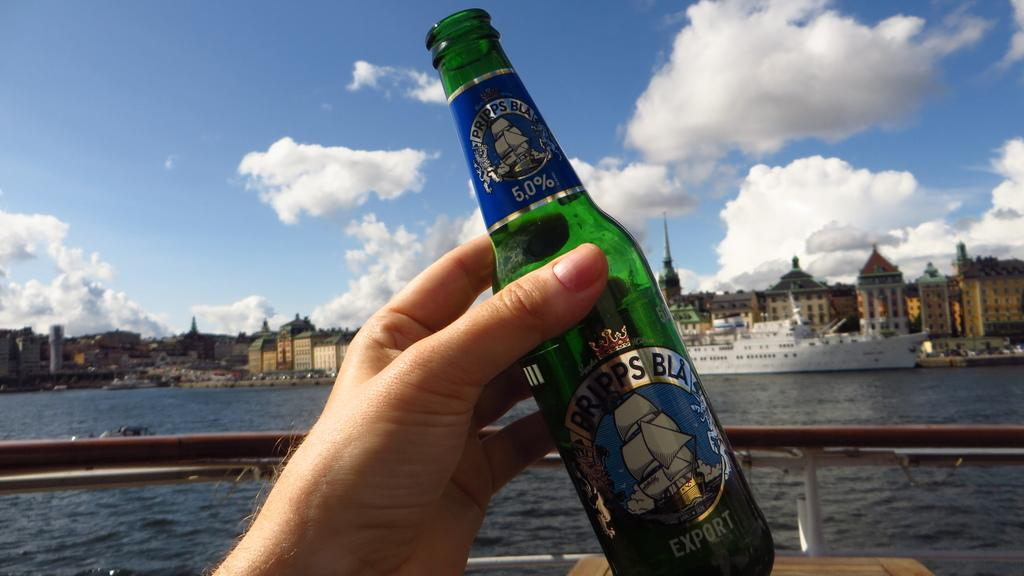<image>
Present a compact description of the photo's key features. A hand grasps an empty bottle of Pripps Bla beer overlooking the water. 